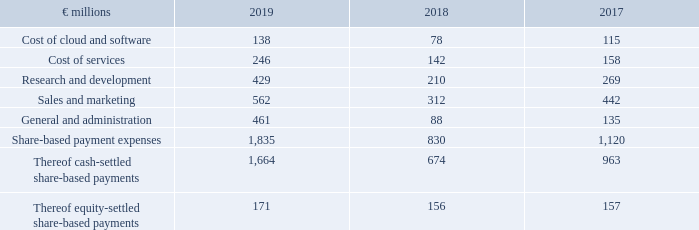The operating expense line items in our income statement include the following share-based payment expenses:
Share-Based Payment Expenses by Functional Area
In 2019, we paid €79 million in share-based payments that became fully vested because of terminations due to operational reasons in connection with our restructuring plan. These payments as well as the expense portion initially allocated to future services were classified as share-based payments and not as restructuring expenses.
Why did the €79 million in share-based payments become fully vested? Because of terminations due to operational reasons in connection with our restructuring plan. these payments as well as the expense portion initially allocated to future services were classified as share-based payments and not as restructuring expenses. What were the Share-based payment expenses in 2019?
Answer scale should be: million. 1,835. In which years were the Share-Based Payment Expenses by Functional Area calculated? 2019, 2018, 2017. In which year was the Cost of cloud and software the largest? 138>115>78
Answer: 2019. What was the change in Cost of cloud and software in 2019 from 2018?
Answer scale should be: million. 138-78
Answer: 60. What was the percentage change in Cost of cloud and software in 2019 from 2018?
Answer scale should be: percent. (138-78)/78
Answer: 76.92. 